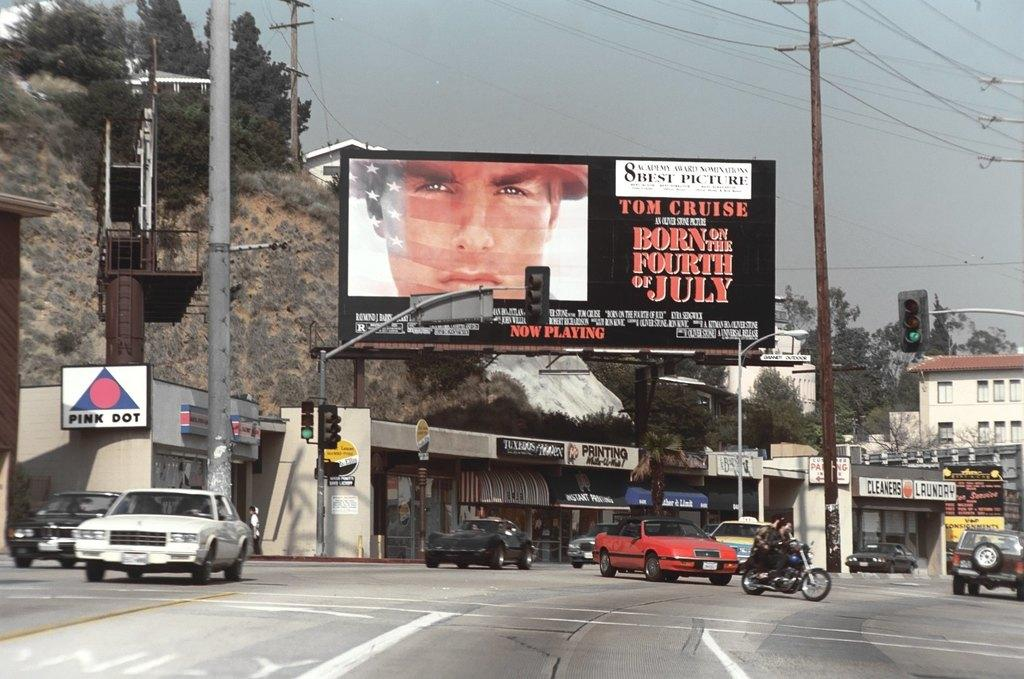<image>
Write a terse but informative summary of the picture. The store-front signs along the street scene include Pink Dot, Tuxedos, Printing, Cleaners and Laundry. 